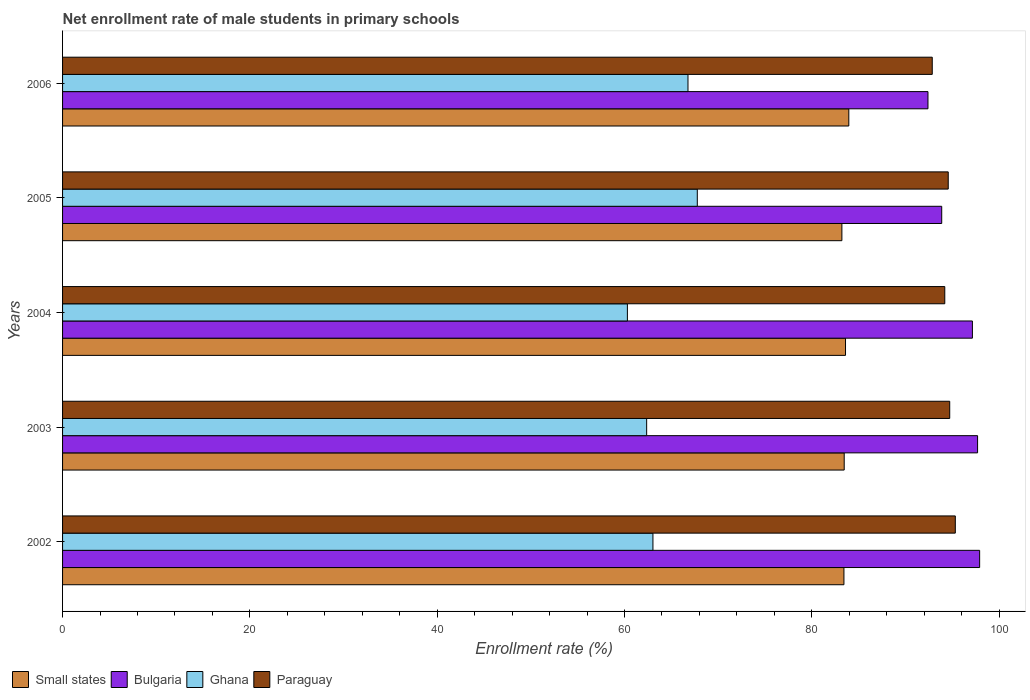How many different coloured bars are there?
Keep it short and to the point. 4. How many bars are there on the 5th tick from the top?
Offer a terse response. 4. In how many cases, is the number of bars for a given year not equal to the number of legend labels?
Your response must be concise. 0. What is the net enrollment rate of male students in primary schools in Ghana in 2005?
Offer a very short reply. 67.77. Across all years, what is the maximum net enrollment rate of male students in primary schools in Small states?
Ensure brevity in your answer.  83.95. Across all years, what is the minimum net enrollment rate of male students in primary schools in Small states?
Make the answer very short. 83.21. In which year was the net enrollment rate of male students in primary schools in Small states maximum?
Offer a terse response. 2006. In which year was the net enrollment rate of male students in primary schools in Paraguay minimum?
Offer a terse response. 2006. What is the total net enrollment rate of male students in primary schools in Small states in the graph?
Give a very brief answer. 417.65. What is the difference between the net enrollment rate of male students in primary schools in Small states in 2002 and that in 2003?
Offer a terse response. -0.03. What is the difference between the net enrollment rate of male students in primary schools in Small states in 2006 and the net enrollment rate of male students in primary schools in Ghana in 2002?
Your answer should be compact. 20.92. What is the average net enrollment rate of male students in primary schools in Paraguay per year?
Ensure brevity in your answer.  94.33. In the year 2002, what is the difference between the net enrollment rate of male students in primary schools in Paraguay and net enrollment rate of male students in primary schools in Small states?
Provide a short and direct response. 11.89. What is the ratio of the net enrollment rate of male students in primary schools in Paraguay in 2002 to that in 2004?
Make the answer very short. 1.01. Is the net enrollment rate of male students in primary schools in Small states in 2002 less than that in 2003?
Your response must be concise. Yes. What is the difference between the highest and the second highest net enrollment rate of male students in primary schools in Paraguay?
Give a very brief answer. 0.6. What is the difference between the highest and the lowest net enrollment rate of male students in primary schools in Small states?
Offer a terse response. 0.74. Is the sum of the net enrollment rate of male students in primary schools in Paraguay in 2002 and 2006 greater than the maximum net enrollment rate of male students in primary schools in Small states across all years?
Your answer should be very brief. Yes. What does the 4th bar from the bottom in 2004 represents?
Offer a terse response. Paraguay. Is it the case that in every year, the sum of the net enrollment rate of male students in primary schools in Paraguay and net enrollment rate of male students in primary schools in Small states is greater than the net enrollment rate of male students in primary schools in Bulgaria?
Offer a terse response. Yes. How many bars are there?
Your response must be concise. 20. Are all the bars in the graph horizontal?
Your answer should be very brief. Yes. How many years are there in the graph?
Provide a short and direct response. 5. Are the values on the major ticks of X-axis written in scientific E-notation?
Your answer should be compact. No. Does the graph contain any zero values?
Make the answer very short. No. Does the graph contain grids?
Your answer should be compact. No. Where does the legend appear in the graph?
Offer a very short reply. Bottom left. How many legend labels are there?
Provide a succinct answer. 4. What is the title of the graph?
Your response must be concise. Net enrollment rate of male students in primary schools. What is the label or title of the X-axis?
Offer a terse response. Enrollment rate (%). What is the label or title of the Y-axis?
Provide a short and direct response. Years. What is the Enrollment rate (%) in Small states in 2002?
Provide a short and direct response. 83.43. What is the Enrollment rate (%) in Bulgaria in 2002?
Your response must be concise. 97.92. What is the Enrollment rate (%) in Ghana in 2002?
Provide a succinct answer. 63.04. What is the Enrollment rate (%) in Paraguay in 2002?
Give a very brief answer. 95.32. What is the Enrollment rate (%) in Small states in 2003?
Offer a very short reply. 83.46. What is the Enrollment rate (%) of Bulgaria in 2003?
Your response must be concise. 97.7. What is the Enrollment rate (%) in Ghana in 2003?
Give a very brief answer. 62.37. What is the Enrollment rate (%) of Paraguay in 2003?
Make the answer very short. 94.72. What is the Enrollment rate (%) of Small states in 2004?
Provide a succinct answer. 83.6. What is the Enrollment rate (%) in Bulgaria in 2004?
Ensure brevity in your answer.  97.15. What is the Enrollment rate (%) of Ghana in 2004?
Offer a very short reply. 60.31. What is the Enrollment rate (%) in Paraguay in 2004?
Your answer should be compact. 94.2. What is the Enrollment rate (%) in Small states in 2005?
Offer a very short reply. 83.21. What is the Enrollment rate (%) in Bulgaria in 2005?
Offer a terse response. 93.87. What is the Enrollment rate (%) of Ghana in 2005?
Your answer should be compact. 67.77. What is the Enrollment rate (%) in Paraguay in 2005?
Provide a succinct answer. 94.57. What is the Enrollment rate (%) in Small states in 2006?
Make the answer very short. 83.95. What is the Enrollment rate (%) in Bulgaria in 2006?
Your answer should be very brief. 92.4. What is the Enrollment rate (%) of Ghana in 2006?
Your answer should be very brief. 66.78. What is the Enrollment rate (%) of Paraguay in 2006?
Provide a succinct answer. 92.86. Across all years, what is the maximum Enrollment rate (%) of Small states?
Your response must be concise. 83.95. Across all years, what is the maximum Enrollment rate (%) of Bulgaria?
Offer a terse response. 97.92. Across all years, what is the maximum Enrollment rate (%) of Ghana?
Provide a succinct answer. 67.77. Across all years, what is the maximum Enrollment rate (%) in Paraguay?
Provide a short and direct response. 95.32. Across all years, what is the minimum Enrollment rate (%) of Small states?
Offer a very short reply. 83.21. Across all years, what is the minimum Enrollment rate (%) of Bulgaria?
Your answer should be very brief. 92.4. Across all years, what is the minimum Enrollment rate (%) of Ghana?
Ensure brevity in your answer.  60.31. Across all years, what is the minimum Enrollment rate (%) in Paraguay?
Make the answer very short. 92.86. What is the total Enrollment rate (%) of Small states in the graph?
Your response must be concise. 417.65. What is the total Enrollment rate (%) of Bulgaria in the graph?
Provide a succinct answer. 479.04. What is the total Enrollment rate (%) in Ghana in the graph?
Keep it short and to the point. 320.26. What is the total Enrollment rate (%) in Paraguay in the graph?
Your response must be concise. 471.67. What is the difference between the Enrollment rate (%) of Small states in 2002 and that in 2003?
Ensure brevity in your answer.  -0.03. What is the difference between the Enrollment rate (%) in Bulgaria in 2002 and that in 2003?
Provide a succinct answer. 0.22. What is the difference between the Enrollment rate (%) in Ghana in 2002 and that in 2003?
Ensure brevity in your answer.  0.67. What is the difference between the Enrollment rate (%) of Paraguay in 2002 and that in 2003?
Your response must be concise. 0.6. What is the difference between the Enrollment rate (%) in Small states in 2002 and that in 2004?
Provide a short and direct response. -0.17. What is the difference between the Enrollment rate (%) of Bulgaria in 2002 and that in 2004?
Offer a terse response. 0.77. What is the difference between the Enrollment rate (%) in Ghana in 2002 and that in 2004?
Your answer should be very brief. 2.73. What is the difference between the Enrollment rate (%) of Paraguay in 2002 and that in 2004?
Provide a short and direct response. 1.12. What is the difference between the Enrollment rate (%) in Small states in 2002 and that in 2005?
Offer a very short reply. 0.22. What is the difference between the Enrollment rate (%) of Bulgaria in 2002 and that in 2005?
Keep it short and to the point. 4.05. What is the difference between the Enrollment rate (%) of Ghana in 2002 and that in 2005?
Offer a terse response. -4.74. What is the difference between the Enrollment rate (%) in Paraguay in 2002 and that in 2005?
Your response must be concise. 0.76. What is the difference between the Enrollment rate (%) in Small states in 2002 and that in 2006?
Offer a very short reply. -0.52. What is the difference between the Enrollment rate (%) in Bulgaria in 2002 and that in 2006?
Make the answer very short. 5.52. What is the difference between the Enrollment rate (%) of Ghana in 2002 and that in 2006?
Your response must be concise. -3.74. What is the difference between the Enrollment rate (%) of Paraguay in 2002 and that in 2006?
Provide a succinct answer. 2.46. What is the difference between the Enrollment rate (%) in Small states in 2003 and that in 2004?
Give a very brief answer. -0.14. What is the difference between the Enrollment rate (%) of Bulgaria in 2003 and that in 2004?
Give a very brief answer. 0.55. What is the difference between the Enrollment rate (%) in Ghana in 2003 and that in 2004?
Give a very brief answer. 2.06. What is the difference between the Enrollment rate (%) of Paraguay in 2003 and that in 2004?
Your answer should be compact. 0.53. What is the difference between the Enrollment rate (%) in Small states in 2003 and that in 2005?
Offer a very short reply. 0.25. What is the difference between the Enrollment rate (%) of Bulgaria in 2003 and that in 2005?
Your answer should be very brief. 3.83. What is the difference between the Enrollment rate (%) in Ghana in 2003 and that in 2005?
Offer a terse response. -5.41. What is the difference between the Enrollment rate (%) in Paraguay in 2003 and that in 2005?
Ensure brevity in your answer.  0.16. What is the difference between the Enrollment rate (%) in Small states in 2003 and that in 2006?
Give a very brief answer. -0.49. What is the difference between the Enrollment rate (%) in Bulgaria in 2003 and that in 2006?
Your answer should be compact. 5.3. What is the difference between the Enrollment rate (%) in Ghana in 2003 and that in 2006?
Keep it short and to the point. -4.41. What is the difference between the Enrollment rate (%) of Paraguay in 2003 and that in 2006?
Your answer should be compact. 1.86. What is the difference between the Enrollment rate (%) in Small states in 2004 and that in 2005?
Make the answer very short. 0.39. What is the difference between the Enrollment rate (%) of Bulgaria in 2004 and that in 2005?
Ensure brevity in your answer.  3.28. What is the difference between the Enrollment rate (%) in Ghana in 2004 and that in 2005?
Your answer should be compact. -7.46. What is the difference between the Enrollment rate (%) in Paraguay in 2004 and that in 2005?
Offer a terse response. -0.37. What is the difference between the Enrollment rate (%) of Small states in 2004 and that in 2006?
Your answer should be very brief. -0.35. What is the difference between the Enrollment rate (%) in Bulgaria in 2004 and that in 2006?
Keep it short and to the point. 4.74. What is the difference between the Enrollment rate (%) of Ghana in 2004 and that in 2006?
Keep it short and to the point. -6.47. What is the difference between the Enrollment rate (%) of Paraguay in 2004 and that in 2006?
Provide a short and direct response. 1.34. What is the difference between the Enrollment rate (%) in Small states in 2005 and that in 2006?
Your answer should be very brief. -0.74. What is the difference between the Enrollment rate (%) of Bulgaria in 2005 and that in 2006?
Ensure brevity in your answer.  1.47. What is the difference between the Enrollment rate (%) of Ghana in 2005 and that in 2006?
Provide a short and direct response. 1. What is the difference between the Enrollment rate (%) of Paraguay in 2005 and that in 2006?
Your response must be concise. 1.71. What is the difference between the Enrollment rate (%) of Small states in 2002 and the Enrollment rate (%) of Bulgaria in 2003?
Your answer should be very brief. -14.27. What is the difference between the Enrollment rate (%) in Small states in 2002 and the Enrollment rate (%) in Ghana in 2003?
Your answer should be compact. 21.06. What is the difference between the Enrollment rate (%) in Small states in 2002 and the Enrollment rate (%) in Paraguay in 2003?
Your answer should be compact. -11.3. What is the difference between the Enrollment rate (%) in Bulgaria in 2002 and the Enrollment rate (%) in Ghana in 2003?
Make the answer very short. 35.55. What is the difference between the Enrollment rate (%) of Bulgaria in 2002 and the Enrollment rate (%) of Paraguay in 2003?
Ensure brevity in your answer.  3.19. What is the difference between the Enrollment rate (%) of Ghana in 2002 and the Enrollment rate (%) of Paraguay in 2003?
Keep it short and to the point. -31.69. What is the difference between the Enrollment rate (%) in Small states in 2002 and the Enrollment rate (%) in Bulgaria in 2004?
Offer a terse response. -13.72. What is the difference between the Enrollment rate (%) of Small states in 2002 and the Enrollment rate (%) of Ghana in 2004?
Keep it short and to the point. 23.12. What is the difference between the Enrollment rate (%) of Small states in 2002 and the Enrollment rate (%) of Paraguay in 2004?
Make the answer very short. -10.77. What is the difference between the Enrollment rate (%) of Bulgaria in 2002 and the Enrollment rate (%) of Ghana in 2004?
Offer a terse response. 37.61. What is the difference between the Enrollment rate (%) of Bulgaria in 2002 and the Enrollment rate (%) of Paraguay in 2004?
Provide a succinct answer. 3.72. What is the difference between the Enrollment rate (%) of Ghana in 2002 and the Enrollment rate (%) of Paraguay in 2004?
Ensure brevity in your answer.  -31.16. What is the difference between the Enrollment rate (%) in Small states in 2002 and the Enrollment rate (%) in Bulgaria in 2005?
Provide a short and direct response. -10.44. What is the difference between the Enrollment rate (%) in Small states in 2002 and the Enrollment rate (%) in Ghana in 2005?
Offer a very short reply. 15.66. What is the difference between the Enrollment rate (%) of Small states in 2002 and the Enrollment rate (%) of Paraguay in 2005?
Provide a succinct answer. -11.14. What is the difference between the Enrollment rate (%) in Bulgaria in 2002 and the Enrollment rate (%) in Ghana in 2005?
Offer a terse response. 30.15. What is the difference between the Enrollment rate (%) of Bulgaria in 2002 and the Enrollment rate (%) of Paraguay in 2005?
Offer a terse response. 3.35. What is the difference between the Enrollment rate (%) of Ghana in 2002 and the Enrollment rate (%) of Paraguay in 2005?
Offer a very short reply. -31.53. What is the difference between the Enrollment rate (%) of Small states in 2002 and the Enrollment rate (%) of Bulgaria in 2006?
Keep it short and to the point. -8.97. What is the difference between the Enrollment rate (%) in Small states in 2002 and the Enrollment rate (%) in Ghana in 2006?
Your answer should be compact. 16.65. What is the difference between the Enrollment rate (%) of Small states in 2002 and the Enrollment rate (%) of Paraguay in 2006?
Provide a short and direct response. -9.43. What is the difference between the Enrollment rate (%) in Bulgaria in 2002 and the Enrollment rate (%) in Ghana in 2006?
Provide a succinct answer. 31.14. What is the difference between the Enrollment rate (%) in Bulgaria in 2002 and the Enrollment rate (%) in Paraguay in 2006?
Ensure brevity in your answer.  5.06. What is the difference between the Enrollment rate (%) of Ghana in 2002 and the Enrollment rate (%) of Paraguay in 2006?
Your answer should be compact. -29.82. What is the difference between the Enrollment rate (%) of Small states in 2003 and the Enrollment rate (%) of Bulgaria in 2004?
Give a very brief answer. -13.69. What is the difference between the Enrollment rate (%) of Small states in 2003 and the Enrollment rate (%) of Ghana in 2004?
Make the answer very short. 23.15. What is the difference between the Enrollment rate (%) of Small states in 2003 and the Enrollment rate (%) of Paraguay in 2004?
Your response must be concise. -10.74. What is the difference between the Enrollment rate (%) in Bulgaria in 2003 and the Enrollment rate (%) in Ghana in 2004?
Your answer should be compact. 37.39. What is the difference between the Enrollment rate (%) of Bulgaria in 2003 and the Enrollment rate (%) of Paraguay in 2004?
Your answer should be compact. 3.5. What is the difference between the Enrollment rate (%) in Ghana in 2003 and the Enrollment rate (%) in Paraguay in 2004?
Ensure brevity in your answer.  -31.83. What is the difference between the Enrollment rate (%) of Small states in 2003 and the Enrollment rate (%) of Bulgaria in 2005?
Your answer should be very brief. -10.41. What is the difference between the Enrollment rate (%) of Small states in 2003 and the Enrollment rate (%) of Ghana in 2005?
Ensure brevity in your answer.  15.69. What is the difference between the Enrollment rate (%) in Small states in 2003 and the Enrollment rate (%) in Paraguay in 2005?
Offer a terse response. -11.11. What is the difference between the Enrollment rate (%) in Bulgaria in 2003 and the Enrollment rate (%) in Ghana in 2005?
Provide a succinct answer. 29.93. What is the difference between the Enrollment rate (%) in Bulgaria in 2003 and the Enrollment rate (%) in Paraguay in 2005?
Offer a terse response. 3.13. What is the difference between the Enrollment rate (%) in Ghana in 2003 and the Enrollment rate (%) in Paraguay in 2005?
Offer a terse response. -32.2. What is the difference between the Enrollment rate (%) in Small states in 2003 and the Enrollment rate (%) in Bulgaria in 2006?
Your answer should be compact. -8.94. What is the difference between the Enrollment rate (%) in Small states in 2003 and the Enrollment rate (%) in Ghana in 2006?
Provide a short and direct response. 16.68. What is the difference between the Enrollment rate (%) of Small states in 2003 and the Enrollment rate (%) of Paraguay in 2006?
Give a very brief answer. -9.4. What is the difference between the Enrollment rate (%) of Bulgaria in 2003 and the Enrollment rate (%) of Ghana in 2006?
Ensure brevity in your answer.  30.92. What is the difference between the Enrollment rate (%) of Bulgaria in 2003 and the Enrollment rate (%) of Paraguay in 2006?
Provide a short and direct response. 4.84. What is the difference between the Enrollment rate (%) of Ghana in 2003 and the Enrollment rate (%) of Paraguay in 2006?
Provide a short and direct response. -30.49. What is the difference between the Enrollment rate (%) of Small states in 2004 and the Enrollment rate (%) of Bulgaria in 2005?
Ensure brevity in your answer.  -10.27. What is the difference between the Enrollment rate (%) in Small states in 2004 and the Enrollment rate (%) in Ghana in 2005?
Provide a short and direct response. 15.83. What is the difference between the Enrollment rate (%) of Small states in 2004 and the Enrollment rate (%) of Paraguay in 2005?
Ensure brevity in your answer.  -10.97. What is the difference between the Enrollment rate (%) in Bulgaria in 2004 and the Enrollment rate (%) in Ghana in 2005?
Offer a terse response. 29.38. What is the difference between the Enrollment rate (%) in Bulgaria in 2004 and the Enrollment rate (%) in Paraguay in 2005?
Your response must be concise. 2.58. What is the difference between the Enrollment rate (%) in Ghana in 2004 and the Enrollment rate (%) in Paraguay in 2005?
Keep it short and to the point. -34.26. What is the difference between the Enrollment rate (%) of Small states in 2004 and the Enrollment rate (%) of Bulgaria in 2006?
Your answer should be very brief. -8.8. What is the difference between the Enrollment rate (%) in Small states in 2004 and the Enrollment rate (%) in Ghana in 2006?
Offer a terse response. 16.82. What is the difference between the Enrollment rate (%) in Small states in 2004 and the Enrollment rate (%) in Paraguay in 2006?
Keep it short and to the point. -9.26. What is the difference between the Enrollment rate (%) of Bulgaria in 2004 and the Enrollment rate (%) of Ghana in 2006?
Your answer should be very brief. 30.37. What is the difference between the Enrollment rate (%) of Bulgaria in 2004 and the Enrollment rate (%) of Paraguay in 2006?
Make the answer very short. 4.29. What is the difference between the Enrollment rate (%) in Ghana in 2004 and the Enrollment rate (%) in Paraguay in 2006?
Provide a succinct answer. -32.55. What is the difference between the Enrollment rate (%) in Small states in 2005 and the Enrollment rate (%) in Bulgaria in 2006?
Provide a succinct answer. -9.19. What is the difference between the Enrollment rate (%) in Small states in 2005 and the Enrollment rate (%) in Ghana in 2006?
Offer a very short reply. 16.43. What is the difference between the Enrollment rate (%) in Small states in 2005 and the Enrollment rate (%) in Paraguay in 2006?
Give a very brief answer. -9.65. What is the difference between the Enrollment rate (%) in Bulgaria in 2005 and the Enrollment rate (%) in Ghana in 2006?
Ensure brevity in your answer.  27.09. What is the difference between the Enrollment rate (%) of Bulgaria in 2005 and the Enrollment rate (%) of Paraguay in 2006?
Your response must be concise. 1.01. What is the difference between the Enrollment rate (%) in Ghana in 2005 and the Enrollment rate (%) in Paraguay in 2006?
Your response must be concise. -25.09. What is the average Enrollment rate (%) in Small states per year?
Give a very brief answer. 83.53. What is the average Enrollment rate (%) in Bulgaria per year?
Your response must be concise. 95.81. What is the average Enrollment rate (%) of Ghana per year?
Ensure brevity in your answer.  64.05. What is the average Enrollment rate (%) of Paraguay per year?
Your response must be concise. 94.33. In the year 2002, what is the difference between the Enrollment rate (%) of Small states and Enrollment rate (%) of Bulgaria?
Give a very brief answer. -14.49. In the year 2002, what is the difference between the Enrollment rate (%) in Small states and Enrollment rate (%) in Ghana?
Your answer should be compact. 20.39. In the year 2002, what is the difference between the Enrollment rate (%) of Small states and Enrollment rate (%) of Paraguay?
Provide a succinct answer. -11.89. In the year 2002, what is the difference between the Enrollment rate (%) of Bulgaria and Enrollment rate (%) of Ghana?
Your answer should be very brief. 34.88. In the year 2002, what is the difference between the Enrollment rate (%) in Bulgaria and Enrollment rate (%) in Paraguay?
Your answer should be very brief. 2.6. In the year 2002, what is the difference between the Enrollment rate (%) in Ghana and Enrollment rate (%) in Paraguay?
Keep it short and to the point. -32.29. In the year 2003, what is the difference between the Enrollment rate (%) in Small states and Enrollment rate (%) in Bulgaria?
Offer a terse response. -14.24. In the year 2003, what is the difference between the Enrollment rate (%) of Small states and Enrollment rate (%) of Ghana?
Offer a very short reply. 21.09. In the year 2003, what is the difference between the Enrollment rate (%) of Small states and Enrollment rate (%) of Paraguay?
Give a very brief answer. -11.27. In the year 2003, what is the difference between the Enrollment rate (%) of Bulgaria and Enrollment rate (%) of Ghana?
Give a very brief answer. 35.33. In the year 2003, what is the difference between the Enrollment rate (%) in Bulgaria and Enrollment rate (%) in Paraguay?
Offer a very short reply. 2.98. In the year 2003, what is the difference between the Enrollment rate (%) in Ghana and Enrollment rate (%) in Paraguay?
Your response must be concise. -32.36. In the year 2004, what is the difference between the Enrollment rate (%) of Small states and Enrollment rate (%) of Bulgaria?
Your response must be concise. -13.55. In the year 2004, what is the difference between the Enrollment rate (%) of Small states and Enrollment rate (%) of Ghana?
Provide a short and direct response. 23.29. In the year 2004, what is the difference between the Enrollment rate (%) in Small states and Enrollment rate (%) in Paraguay?
Your answer should be very brief. -10.6. In the year 2004, what is the difference between the Enrollment rate (%) in Bulgaria and Enrollment rate (%) in Ghana?
Your answer should be very brief. 36.84. In the year 2004, what is the difference between the Enrollment rate (%) of Bulgaria and Enrollment rate (%) of Paraguay?
Provide a succinct answer. 2.95. In the year 2004, what is the difference between the Enrollment rate (%) in Ghana and Enrollment rate (%) in Paraguay?
Make the answer very short. -33.89. In the year 2005, what is the difference between the Enrollment rate (%) in Small states and Enrollment rate (%) in Bulgaria?
Make the answer very short. -10.66. In the year 2005, what is the difference between the Enrollment rate (%) in Small states and Enrollment rate (%) in Ghana?
Offer a terse response. 15.44. In the year 2005, what is the difference between the Enrollment rate (%) of Small states and Enrollment rate (%) of Paraguay?
Provide a succinct answer. -11.35. In the year 2005, what is the difference between the Enrollment rate (%) in Bulgaria and Enrollment rate (%) in Ghana?
Offer a terse response. 26.1. In the year 2005, what is the difference between the Enrollment rate (%) in Bulgaria and Enrollment rate (%) in Paraguay?
Keep it short and to the point. -0.7. In the year 2005, what is the difference between the Enrollment rate (%) of Ghana and Enrollment rate (%) of Paraguay?
Keep it short and to the point. -26.79. In the year 2006, what is the difference between the Enrollment rate (%) in Small states and Enrollment rate (%) in Bulgaria?
Keep it short and to the point. -8.45. In the year 2006, what is the difference between the Enrollment rate (%) in Small states and Enrollment rate (%) in Ghana?
Ensure brevity in your answer.  17.17. In the year 2006, what is the difference between the Enrollment rate (%) in Small states and Enrollment rate (%) in Paraguay?
Make the answer very short. -8.91. In the year 2006, what is the difference between the Enrollment rate (%) of Bulgaria and Enrollment rate (%) of Ghana?
Ensure brevity in your answer.  25.63. In the year 2006, what is the difference between the Enrollment rate (%) of Bulgaria and Enrollment rate (%) of Paraguay?
Your answer should be compact. -0.46. In the year 2006, what is the difference between the Enrollment rate (%) in Ghana and Enrollment rate (%) in Paraguay?
Ensure brevity in your answer.  -26.08. What is the ratio of the Enrollment rate (%) of Bulgaria in 2002 to that in 2003?
Offer a very short reply. 1. What is the ratio of the Enrollment rate (%) of Ghana in 2002 to that in 2003?
Provide a succinct answer. 1.01. What is the ratio of the Enrollment rate (%) of Small states in 2002 to that in 2004?
Offer a very short reply. 1. What is the ratio of the Enrollment rate (%) in Bulgaria in 2002 to that in 2004?
Your answer should be very brief. 1.01. What is the ratio of the Enrollment rate (%) of Ghana in 2002 to that in 2004?
Offer a very short reply. 1.05. What is the ratio of the Enrollment rate (%) in Paraguay in 2002 to that in 2004?
Give a very brief answer. 1.01. What is the ratio of the Enrollment rate (%) in Bulgaria in 2002 to that in 2005?
Offer a terse response. 1.04. What is the ratio of the Enrollment rate (%) of Ghana in 2002 to that in 2005?
Your answer should be compact. 0.93. What is the ratio of the Enrollment rate (%) of Small states in 2002 to that in 2006?
Keep it short and to the point. 0.99. What is the ratio of the Enrollment rate (%) in Bulgaria in 2002 to that in 2006?
Provide a short and direct response. 1.06. What is the ratio of the Enrollment rate (%) in Ghana in 2002 to that in 2006?
Your response must be concise. 0.94. What is the ratio of the Enrollment rate (%) in Paraguay in 2002 to that in 2006?
Keep it short and to the point. 1.03. What is the ratio of the Enrollment rate (%) in Ghana in 2003 to that in 2004?
Make the answer very short. 1.03. What is the ratio of the Enrollment rate (%) of Paraguay in 2003 to that in 2004?
Offer a very short reply. 1.01. What is the ratio of the Enrollment rate (%) in Bulgaria in 2003 to that in 2005?
Provide a succinct answer. 1.04. What is the ratio of the Enrollment rate (%) in Ghana in 2003 to that in 2005?
Provide a succinct answer. 0.92. What is the ratio of the Enrollment rate (%) of Paraguay in 2003 to that in 2005?
Provide a short and direct response. 1. What is the ratio of the Enrollment rate (%) in Bulgaria in 2003 to that in 2006?
Keep it short and to the point. 1.06. What is the ratio of the Enrollment rate (%) of Ghana in 2003 to that in 2006?
Provide a succinct answer. 0.93. What is the ratio of the Enrollment rate (%) of Paraguay in 2003 to that in 2006?
Give a very brief answer. 1.02. What is the ratio of the Enrollment rate (%) in Bulgaria in 2004 to that in 2005?
Offer a terse response. 1.03. What is the ratio of the Enrollment rate (%) of Ghana in 2004 to that in 2005?
Offer a terse response. 0.89. What is the ratio of the Enrollment rate (%) in Bulgaria in 2004 to that in 2006?
Your response must be concise. 1.05. What is the ratio of the Enrollment rate (%) in Ghana in 2004 to that in 2006?
Offer a terse response. 0.9. What is the ratio of the Enrollment rate (%) in Paraguay in 2004 to that in 2006?
Offer a terse response. 1.01. What is the ratio of the Enrollment rate (%) in Bulgaria in 2005 to that in 2006?
Your answer should be very brief. 1.02. What is the ratio of the Enrollment rate (%) in Ghana in 2005 to that in 2006?
Offer a terse response. 1.01. What is the ratio of the Enrollment rate (%) of Paraguay in 2005 to that in 2006?
Make the answer very short. 1.02. What is the difference between the highest and the second highest Enrollment rate (%) of Small states?
Your answer should be compact. 0.35. What is the difference between the highest and the second highest Enrollment rate (%) of Bulgaria?
Offer a terse response. 0.22. What is the difference between the highest and the second highest Enrollment rate (%) of Ghana?
Provide a succinct answer. 1. What is the difference between the highest and the second highest Enrollment rate (%) in Paraguay?
Offer a very short reply. 0.6. What is the difference between the highest and the lowest Enrollment rate (%) in Small states?
Offer a terse response. 0.74. What is the difference between the highest and the lowest Enrollment rate (%) of Bulgaria?
Your answer should be very brief. 5.52. What is the difference between the highest and the lowest Enrollment rate (%) of Ghana?
Your answer should be very brief. 7.46. What is the difference between the highest and the lowest Enrollment rate (%) of Paraguay?
Make the answer very short. 2.46. 